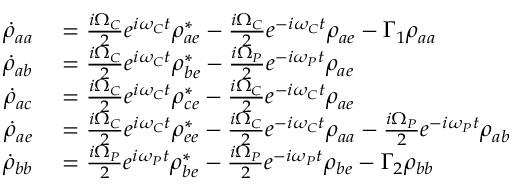<formula> <loc_0><loc_0><loc_500><loc_500>\begin{array} { r l } { \dot { \rho } _ { a a } } & = \frac { i \Omega _ { C } } { 2 } e ^ { i \omega _ { C } t } \rho _ { a e } ^ { * } - \frac { i \Omega _ { C } } { 2 } e ^ { - i \omega _ { C } t } \rho _ { a e } - \Gamma _ { 1 } \rho _ { a a } } \\ { \dot { \rho } _ { a b } } & = \frac { i \Omega _ { C } } { 2 } e ^ { i \omega _ { C } t } \rho _ { b e } ^ { * } - \frac { i \Omega _ { P } } { 2 } e ^ { - i \omega _ { P } t } \rho _ { a e } } \\ { \dot { \rho } _ { a c } } & = \frac { i \Omega _ { C } } { 2 } e ^ { i \omega _ { C } t } \rho _ { c e } ^ { * } - \frac { i \Omega _ { C } } { 2 } e ^ { - i \omega _ { C } t } \rho _ { a e } } \\ { \dot { \rho } _ { a e } } & = \frac { i \Omega _ { C } } { 2 } e ^ { i \omega _ { C } t } \rho _ { e e } ^ { * } - \frac { i \Omega _ { C } } { 2 } e ^ { - i \omega _ { C } t } \rho _ { a a } - \frac { i \Omega _ { P } } { 2 } e ^ { - i \omega _ { P } t } \rho _ { a b } } \\ { \dot { \rho } _ { b b } } & = \frac { i \Omega _ { P } } { 2 } e ^ { i \omega _ { P } t } \rho _ { b e } ^ { * } - \frac { i \Omega _ { P } } { 2 } e ^ { - i \omega _ { P } t } \rho _ { b e } - \Gamma _ { 2 } \rho _ { b b } } \end{array}</formula> 